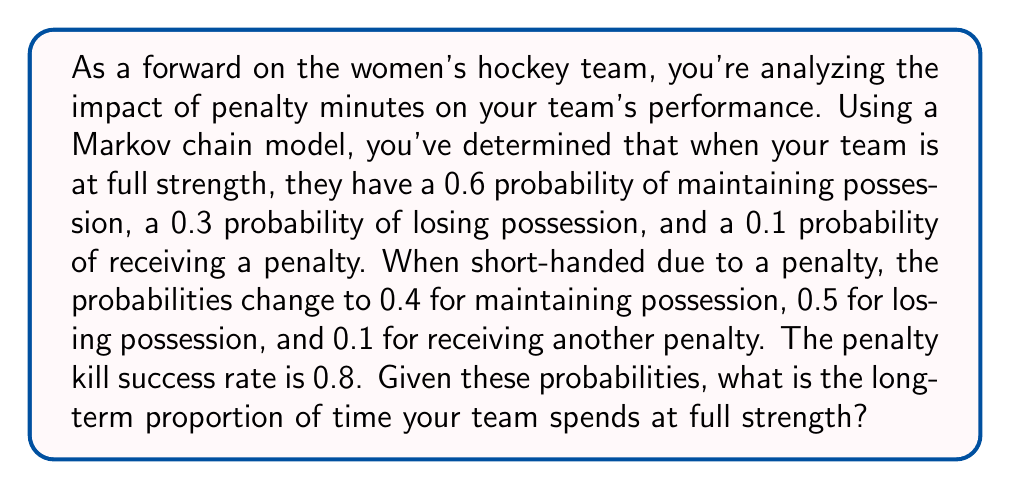Show me your answer to this math problem. To solve this problem, we'll use a Markov chain with two states: Full Strength (F) and Short-handed (S). Let's follow these steps:

1. Define the transition matrix:
   $$P = \begin{bmatrix}
   0.9 & 0.1 \\
   0.8 & 0.2
   \end{bmatrix}$$
   Where:
   - $P_{FF} = 0.9$ (probability of staying at full strength)
   - $P_{FS} = 0.1$ (probability of getting a penalty)
   - $P_{SF} = 0.8$ (probability of successful penalty kill)
   - $P_{SS} = 0.2$ (probability of staying short-handed)

2. Find the stationary distribution by solving the equation:
   $$\pi P = \pi$$
   Where $\pi = [\pi_F, \pi_S]$ is the stationary distribution.

3. This gives us the system of equations:
   $$\begin{cases}
   0.9\pi_F + 0.8\pi_S = \pi_F \\
   0.1\pi_F + 0.2\pi_S = \pi_S
   \end{cases}$$

4. We also know that $\pi_F + \pi_S = 1$

5. Solving this system:
   From the first equation: $0.8\pi_S = 0.1\pi_F$
   $\pi_S = \frac{1}{8}\pi_F$

   Substituting into $\pi_F + \pi_S = 1$:
   $\pi_F + \frac{1}{8}\pi_F = 1$
   $\frac{9}{8}\pi_F = 1$
   $\pi_F = \frac{8}{9} \approx 0.8889$

6. Therefore, the long-term proportion of time spent at full strength is $\frac{8}{9}$ or approximately 0.8889 or 88.89%.
Answer: $\frac{8}{9}$ or approximately 0.8889 or 88.89% 